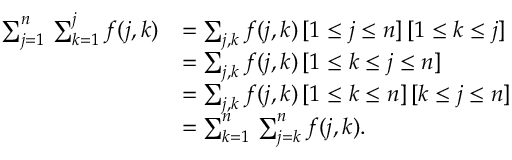<formula> <loc_0><loc_0><loc_500><loc_500>{ \begin{array} { r l } { \sum _ { j = 1 } ^ { n } \, \sum _ { k = 1 } ^ { j } f ( j , k ) } & { = \sum _ { j , k } f ( j , k ) \, [ 1 \leq j \leq n ] \, [ 1 \leq k \leq j ] } \\ & { = \sum _ { j , k } f ( j , k ) \, [ 1 \leq k \leq j \leq n ] } \\ & { = \sum _ { j , k } f ( j , k ) \, [ 1 \leq k \leq n ] \, [ k \leq j \leq n ] } \\ & { = \sum _ { k = 1 } ^ { n } \, \sum _ { j = k } ^ { n } f ( j , k ) . } \end{array} }</formula> 